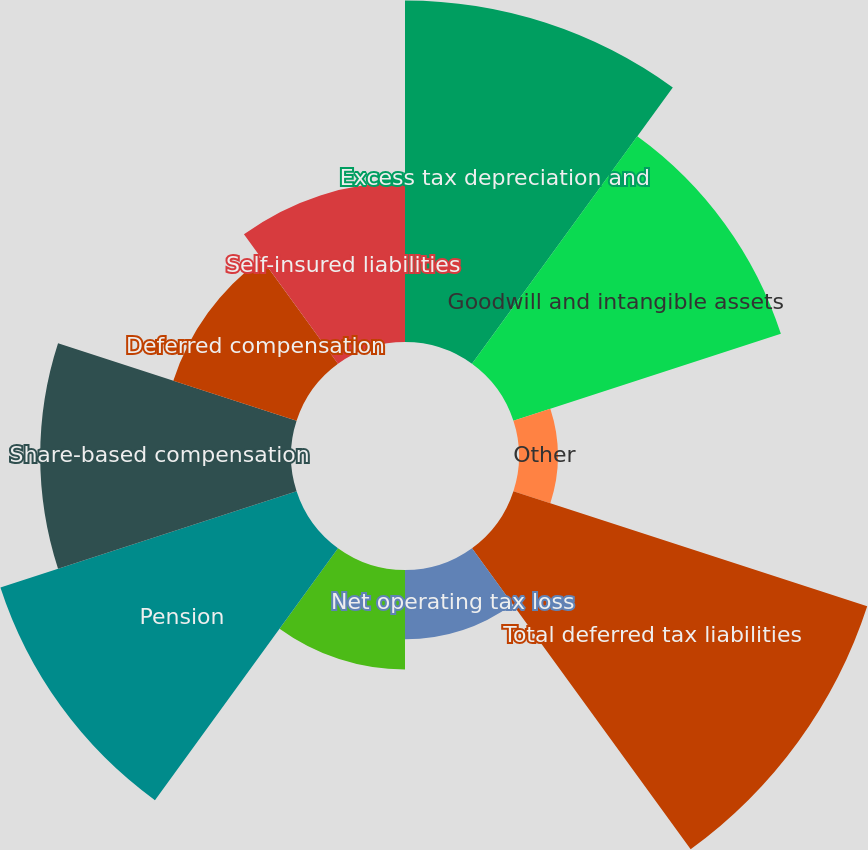Convert chart to OTSL. <chart><loc_0><loc_0><loc_500><loc_500><pie_chart><fcel>Excess tax depreciation and<fcel>Goodwill and intangible assets<fcel>Other<fcel>Total deferred tax liabilities<fcel>Net operating tax loss<fcel>Benefit on unrecognized tax<fcel>Pension<fcel>Share-based compensation<fcel>Deferred compensation<fcel>Self-insured liabilities<nl><fcel>16.63%<fcel>13.69%<fcel>1.89%<fcel>18.11%<fcel>3.37%<fcel>4.84%<fcel>15.16%<fcel>12.21%<fcel>6.31%<fcel>7.79%<nl></chart> 